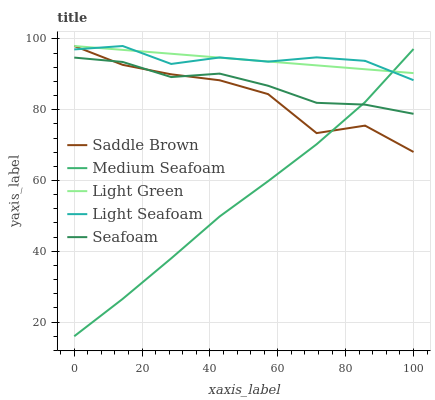Does Medium Seafoam have the minimum area under the curve?
Answer yes or no. Yes. Does Light Seafoam have the maximum area under the curve?
Answer yes or no. Yes. Does Seafoam have the minimum area under the curve?
Answer yes or no. No. Does Seafoam have the maximum area under the curve?
Answer yes or no. No. Is Light Green the smoothest?
Answer yes or no. Yes. Is Saddle Brown the roughest?
Answer yes or no. Yes. Is Seafoam the smoothest?
Answer yes or no. No. Is Seafoam the roughest?
Answer yes or no. No. Does Seafoam have the lowest value?
Answer yes or no. No. Does Light Green have the highest value?
Answer yes or no. Yes. Does Seafoam have the highest value?
Answer yes or no. No. Is Seafoam less than Light Green?
Answer yes or no. Yes. Is Light Green greater than Seafoam?
Answer yes or no. Yes. Does Seafoam intersect Saddle Brown?
Answer yes or no. Yes. Is Seafoam less than Saddle Brown?
Answer yes or no. No. Is Seafoam greater than Saddle Brown?
Answer yes or no. No. Does Seafoam intersect Light Green?
Answer yes or no. No. 